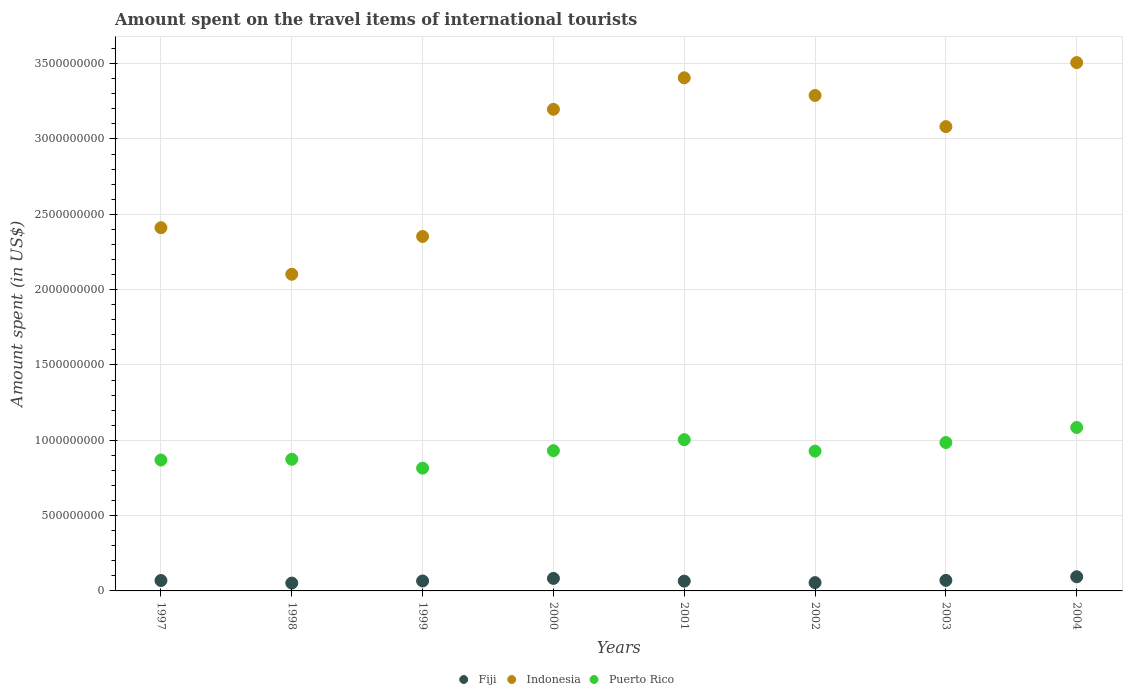What is the amount spent on the travel items of international tourists in Indonesia in 2000?
Ensure brevity in your answer.  3.20e+09. Across all years, what is the maximum amount spent on the travel items of international tourists in Fiji?
Keep it short and to the point. 9.40e+07. Across all years, what is the minimum amount spent on the travel items of international tourists in Puerto Rico?
Provide a short and direct response. 8.15e+08. What is the total amount spent on the travel items of international tourists in Puerto Rico in the graph?
Give a very brief answer. 7.49e+09. What is the difference between the amount spent on the travel items of international tourists in Puerto Rico in 1999 and that in 2003?
Ensure brevity in your answer.  -1.70e+08. What is the difference between the amount spent on the travel items of international tourists in Fiji in 1998 and the amount spent on the travel items of international tourists in Indonesia in 2002?
Your response must be concise. -3.24e+09. What is the average amount spent on the travel items of international tourists in Indonesia per year?
Offer a terse response. 2.92e+09. In the year 1999, what is the difference between the amount spent on the travel items of international tourists in Indonesia and amount spent on the travel items of international tourists in Puerto Rico?
Keep it short and to the point. 1.54e+09. In how many years, is the amount spent on the travel items of international tourists in Puerto Rico greater than 3200000000 US$?
Your answer should be very brief. 0. What is the ratio of the amount spent on the travel items of international tourists in Fiji in 1998 to that in 2004?
Your response must be concise. 0.55. What is the difference between the highest and the second highest amount spent on the travel items of international tourists in Puerto Rico?
Keep it short and to the point. 8.10e+07. What is the difference between the highest and the lowest amount spent on the travel items of international tourists in Fiji?
Your answer should be very brief. 4.20e+07. Is the sum of the amount spent on the travel items of international tourists in Fiji in 2000 and 2001 greater than the maximum amount spent on the travel items of international tourists in Indonesia across all years?
Offer a terse response. No. Does the amount spent on the travel items of international tourists in Fiji monotonically increase over the years?
Make the answer very short. No. Is the amount spent on the travel items of international tourists in Puerto Rico strictly greater than the amount spent on the travel items of international tourists in Indonesia over the years?
Your response must be concise. No. Is the amount spent on the travel items of international tourists in Puerto Rico strictly less than the amount spent on the travel items of international tourists in Fiji over the years?
Make the answer very short. No. Does the graph contain any zero values?
Your answer should be compact. No. How are the legend labels stacked?
Your answer should be compact. Horizontal. What is the title of the graph?
Your response must be concise. Amount spent on the travel items of international tourists. Does "Luxembourg" appear as one of the legend labels in the graph?
Your answer should be very brief. No. What is the label or title of the X-axis?
Offer a terse response. Years. What is the label or title of the Y-axis?
Provide a succinct answer. Amount spent (in US$). What is the Amount spent (in US$) of Fiji in 1997?
Your answer should be compact. 6.90e+07. What is the Amount spent (in US$) in Indonesia in 1997?
Offer a terse response. 2.41e+09. What is the Amount spent (in US$) in Puerto Rico in 1997?
Offer a terse response. 8.69e+08. What is the Amount spent (in US$) in Fiji in 1998?
Make the answer very short. 5.20e+07. What is the Amount spent (in US$) in Indonesia in 1998?
Give a very brief answer. 2.10e+09. What is the Amount spent (in US$) of Puerto Rico in 1998?
Provide a succinct answer. 8.74e+08. What is the Amount spent (in US$) in Fiji in 1999?
Make the answer very short. 6.60e+07. What is the Amount spent (in US$) in Indonesia in 1999?
Your answer should be compact. 2.35e+09. What is the Amount spent (in US$) of Puerto Rico in 1999?
Ensure brevity in your answer.  8.15e+08. What is the Amount spent (in US$) in Fiji in 2000?
Make the answer very short. 8.30e+07. What is the Amount spent (in US$) in Indonesia in 2000?
Offer a terse response. 3.20e+09. What is the Amount spent (in US$) in Puerto Rico in 2000?
Make the answer very short. 9.31e+08. What is the Amount spent (in US$) of Fiji in 2001?
Provide a short and direct response. 6.50e+07. What is the Amount spent (in US$) of Indonesia in 2001?
Ensure brevity in your answer.  3.41e+09. What is the Amount spent (in US$) in Puerto Rico in 2001?
Your answer should be very brief. 1.00e+09. What is the Amount spent (in US$) in Fiji in 2002?
Ensure brevity in your answer.  5.50e+07. What is the Amount spent (in US$) of Indonesia in 2002?
Keep it short and to the point. 3.29e+09. What is the Amount spent (in US$) in Puerto Rico in 2002?
Ensure brevity in your answer.  9.28e+08. What is the Amount spent (in US$) of Fiji in 2003?
Make the answer very short. 7.00e+07. What is the Amount spent (in US$) in Indonesia in 2003?
Provide a succinct answer. 3.08e+09. What is the Amount spent (in US$) of Puerto Rico in 2003?
Keep it short and to the point. 9.85e+08. What is the Amount spent (in US$) in Fiji in 2004?
Your answer should be very brief. 9.40e+07. What is the Amount spent (in US$) of Indonesia in 2004?
Give a very brief answer. 3.51e+09. What is the Amount spent (in US$) of Puerto Rico in 2004?
Provide a short and direct response. 1.08e+09. Across all years, what is the maximum Amount spent (in US$) of Fiji?
Keep it short and to the point. 9.40e+07. Across all years, what is the maximum Amount spent (in US$) in Indonesia?
Offer a terse response. 3.51e+09. Across all years, what is the maximum Amount spent (in US$) of Puerto Rico?
Offer a terse response. 1.08e+09. Across all years, what is the minimum Amount spent (in US$) of Fiji?
Your response must be concise. 5.20e+07. Across all years, what is the minimum Amount spent (in US$) of Indonesia?
Make the answer very short. 2.10e+09. Across all years, what is the minimum Amount spent (in US$) in Puerto Rico?
Your answer should be compact. 8.15e+08. What is the total Amount spent (in US$) in Fiji in the graph?
Your answer should be very brief. 5.54e+08. What is the total Amount spent (in US$) of Indonesia in the graph?
Offer a terse response. 2.33e+1. What is the total Amount spent (in US$) in Puerto Rico in the graph?
Make the answer very short. 7.49e+09. What is the difference between the Amount spent (in US$) of Fiji in 1997 and that in 1998?
Your answer should be very brief. 1.70e+07. What is the difference between the Amount spent (in US$) in Indonesia in 1997 and that in 1998?
Give a very brief answer. 3.09e+08. What is the difference between the Amount spent (in US$) of Puerto Rico in 1997 and that in 1998?
Give a very brief answer. -5.00e+06. What is the difference between the Amount spent (in US$) in Fiji in 1997 and that in 1999?
Ensure brevity in your answer.  3.00e+06. What is the difference between the Amount spent (in US$) of Indonesia in 1997 and that in 1999?
Provide a succinct answer. 5.80e+07. What is the difference between the Amount spent (in US$) in Puerto Rico in 1997 and that in 1999?
Make the answer very short. 5.40e+07. What is the difference between the Amount spent (in US$) of Fiji in 1997 and that in 2000?
Offer a terse response. -1.40e+07. What is the difference between the Amount spent (in US$) of Indonesia in 1997 and that in 2000?
Provide a succinct answer. -7.86e+08. What is the difference between the Amount spent (in US$) in Puerto Rico in 1997 and that in 2000?
Keep it short and to the point. -6.20e+07. What is the difference between the Amount spent (in US$) of Fiji in 1997 and that in 2001?
Your response must be concise. 4.00e+06. What is the difference between the Amount spent (in US$) of Indonesia in 1997 and that in 2001?
Ensure brevity in your answer.  -9.95e+08. What is the difference between the Amount spent (in US$) of Puerto Rico in 1997 and that in 2001?
Give a very brief answer. -1.35e+08. What is the difference between the Amount spent (in US$) in Fiji in 1997 and that in 2002?
Keep it short and to the point. 1.40e+07. What is the difference between the Amount spent (in US$) in Indonesia in 1997 and that in 2002?
Make the answer very short. -8.78e+08. What is the difference between the Amount spent (in US$) of Puerto Rico in 1997 and that in 2002?
Provide a short and direct response. -5.90e+07. What is the difference between the Amount spent (in US$) of Indonesia in 1997 and that in 2003?
Ensure brevity in your answer.  -6.71e+08. What is the difference between the Amount spent (in US$) of Puerto Rico in 1997 and that in 2003?
Keep it short and to the point. -1.16e+08. What is the difference between the Amount spent (in US$) in Fiji in 1997 and that in 2004?
Provide a succinct answer. -2.50e+07. What is the difference between the Amount spent (in US$) in Indonesia in 1997 and that in 2004?
Provide a succinct answer. -1.10e+09. What is the difference between the Amount spent (in US$) of Puerto Rico in 1997 and that in 2004?
Provide a succinct answer. -2.16e+08. What is the difference between the Amount spent (in US$) in Fiji in 1998 and that in 1999?
Provide a short and direct response. -1.40e+07. What is the difference between the Amount spent (in US$) of Indonesia in 1998 and that in 1999?
Give a very brief answer. -2.51e+08. What is the difference between the Amount spent (in US$) of Puerto Rico in 1998 and that in 1999?
Your response must be concise. 5.90e+07. What is the difference between the Amount spent (in US$) in Fiji in 1998 and that in 2000?
Give a very brief answer. -3.10e+07. What is the difference between the Amount spent (in US$) in Indonesia in 1998 and that in 2000?
Your answer should be compact. -1.10e+09. What is the difference between the Amount spent (in US$) of Puerto Rico in 1998 and that in 2000?
Offer a terse response. -5.70e+07. What is the difference between the Amount spent (in US$) in Fiji in 1998 and that in 2001?
Offer a terse response. -1.30e+07. What is the difference between the Amount spent (in US$) in Indonesia in 1998 and that in 2001?
Keep it short and to the point. -1.30e+09. What is the difference between the Amount spent (in US$) in Puerto Rico in 1998 and that in 2001?
Provide a succinct answer. -1.30e+08. What is the difference between the Amount spent (in US$) of Indonesia in 1998 and that in 2002?
Your answer should be very brief. -1.19e+09. What is the difference between the Amount spent (in US$) in Puerto Rico in 1998 and that in 2002?
Make the answer very short. -5.40e+07. What is the difference between the Amount spent (in US$) in Fiji in 1998 and that in 2003?
Offer a very short reply. -1.80e+07. What is the difference between the Amount spent (in US$) in Indonesia in 1998 and that in 2003?
Make the answer very short. -9.80e+08. What is the difference between the Amount spent (in US$) in Puerto Rico in 1998 and that in 2003?
Ensure brevity in your answer.  -1.11e+08. What is the difference between the Amount spent (in US$) in Fiji in 1998 and that in 2004?
Your answer should be very brief. -4.20e+07. What is the difference between the Amount spent (in US$) of Indonesia in 1998 and that in 2004?
Your response must be concise. -1.40e+09. What is the difference between the Amount spent (in US$) of Puerto Rico in 1998 and that in 2004?
Make the answer very short. -2.11e+08. What is the difference between the Amount spent (in US$) in Fiji in 1999 and that in 2000?
Your answer should be very brief. -1.70e+07. What is the difference between the Amount spent (in US$) in Indonesia in 1999 and that in 2000?
Keep it short and to the point. -8.44e+08. What is the difference between the Amount spent (in US$) of Puerto Rico in 1999 and that in 2000?
Your response must be concise. -1.16e+08. What is the difference between the Amount spent (in US$) of Indonesia in 1999 and that in 2001?
Provide a short and direct response. -1.05e+09. What is the difference between the Amount spent (in US$) in Puerto Rico in 1999 and that in 2001?
Make the answer very short. -1.89e+08. What is the difference between the Amount spent (in US$) in Fiji in 1999 and that in 2002?
Ensure brevity in your answer.  1.10e+07. What is the difference between the Amount spent (in US$) in Indonesia in 1999 and that in 2002?
Your answer should be compact. -9.36e+08. What is the difference between the Amount spent (in US$) of Puerto Rico in 1999 and that in 2002?
Your answer should be compact. -1.13e+08. What is the difference between the Amount spent (in US$) in Fiji in 1999 and that in 2003?
Provide a succinct answer. -4.00e+06. What is the difference between the Amount spent (in US$) of Indonesia in 1999 and that in 2003?
Keep it short and to the point. -7.29e+08. What is the difference between the Amount spent (in US$) in Puerto Rico in 1999 and that in 2003?
Provide a succinct answer. -1.70e+08. What is the difference between the Amount spent (in US$) of Fiji in 1999 and that in 2004?
Ensure brevity in your answer.  -2.80e+07. What is the difference between the Amount spent (in US$) of Indonesia in 1999 and that in 2004?
Offer a very short reply. -1.15e+09. What is the difference between the Amount spent (in US$) of Puerto Rico in 1999 and that in 2004?
Make the answer very short. -2.70e+08. What is the difference between the Amount spent (in US$) in Fiji in 2000 and that in 2001?
Make the answer very short. 1.80e+07. What is the difference between the Amount spent (in US$) of Indonesia in 2000 and that in 2001?
Make the answer very short. -2.09e+08. What is the difference between the Amount spent (in US$) in Puerto Rico in 2000 and that in 2001?
Provide a succinct answer. -7.30e+07. What is the difference between the Amount spent (in US$) of Fiji in 2000 and that in 2002?
Your answer should be compact. 2.80e+07. What is the difference between the Amount spent (in US$) of Indonesia in 2000 and that in 2002?
Provide a short and direct response. -9.20e+07. What is the difference between the Amount spent (in US$) of Fiji in 2000 and that in 2003?
Keep it short and to the point. 1.30e+07. What is the difference between the Amount spent (in US$) of Indonesia in 2000 and that in 2003?
Your answer should be compact. 1.15e+08. What is the difference between the Amount spent (in US$) of Puerto Rico in 2000 and that in 2003?
Your answer should be very brief. -5.40e+07. What is the difference between the Amount spent (in US$) in Fiji in 2000 and that in 2004?
Ensure brevity in your answer.  -1.10e+07. What is the difference between the Amount spent (in US$) of Indonesia in 2000 and that in 2004?
Offer a very short reply. -3.10e+08. What is the difference between the Amount spent (in US$) in Puerto Rico in 2000 and that in 2004?
Provide a succinct answer. -1.54e+08. What is the difference between the Amount spent (in US$) of Indonesia in 2001 and that in 2002?
Your response must be concise. 1.17e+08. What is the difference between the Amount spent (in US$) of Puerto Rico in 2001 and that in 2002?
Ensure brevity in your answer.  7.60e+07. What is the difference between the Amount spent (in US$) in Fiji in 2001 and that in 2003?
Give a very brief answer. -5.00e+06. What is the difference between the Amount spent (in US$) in Indonesia in 2001 and that in 2003?
Your answer should be compact. 3.24e+08. What is the difference between the Amount spent (in US$) in Puerto Rico in 2001 and that in 2003?
Your answer should be very brief. 1.90e+07. What is the difference between the Amount spent (in US$) of Fiji in 2001 and that in 2004?
Provide a succinct answer. -2.90e+07. What is the difference between the Amount spent (in US$) of Indonesia in 2001 and that in 2004?
Provide a succinct answer. -1.01e+08. What is the difference between the Amount spent (in US$) in Puerto Rico in 2001 and that in 2004?
Your answer should be very brief. -8.10e+07. What is the difference between the Amount spent (in US$) in Fiji in 2002 and that in 2003?
Keep it short and to the point. -1.50e+07. What is the difference between the Amount spent (in US$) of Indonesia in 2002 and that in 2003?
Give a very brief answer. 2.07e+08. What is the difference between the Amount spent (in US$) of Puerto Rico in 2002 and that in 2003?
Give a very brief answer. -5.70e+07. What is the difference between the Amount spent (in US$) in Fiji in 2002 and that in 2004?
Your answer should be compact. -3.90e+07. What is the difference between the Amount spent (in US$) in Indonesia in 2002 and that in 2004?
Provide a short and direct response. -2.18e+08. What is the difference between the Amount spent (in US$) of Puerto Rico in 2002 and that in 2004?
Provide a succinct answer. -1.57e+08. What is the difference between the Amount spent (in US$) in Fiji in 2003 and that in 2004?
Ensure brevity in your answer.  -2.40e+07. What is the difference between the Amount spent (in US$) of Indonesia in 2003 and that in 2004?
Provide a short and direct response. -4.25e+08. What is the difference between the Amount spent (in US$) in Puerto Rico in 2003 and that in 2004?
Your answer should be compact. -1.00e+08. What is the difference between the Amount spent (in US$) in Fiji in 1997 and the Amount spent (in US$) in Indonesia in 1998?
Offer a terse response. -2.03e+09. What is the difference between the Amount spent (in US$) in Fiji in 1997 and the Amount spent (in US$) in Puerto Rico in 1998?
Your answer should be compact. -8.05e+08. What is the difference between the Amount spent (in US$) in Indonesia in 1997 and the Amount spent (in US$) in Puerto Rico in 1998?
Provide a succinct answer. 1.54e+09. What is the difference between the Amount spent (in US$) of Fiji in 1997 and the Amount spent (in US$) of Indonesia in 1999?
Your answer should be compact. -2.28e+09. What is the difference between the Amount spent (in US$) of Fiji in 1997 and the Amount spent (in US$) of Puerto Rico in 1999?
Provide a succinct answer. -7.46e+08. What is the difference between the Amount spent (in US$) of Indonesia in 1997 and the Amount spent (in US$) of Puerto Rico in 1999?
Your answer should be compact. 1.60e+09. What is the difference between the Amount spent (in US$) of Fiji in 1997 and the Amount spent (in US$) of Indonesia in 2000?
Offer a terse response. -3.13e+09. What is the difference between the Amount spent (in US$) of Fiji in 1997 and the Amount spent (in US$) of Puerto Rico in 2000?
Your answer should be compact. -8.62e+08. What is the difference between the Amount spent (in US$) of Indonesia in 1997 and the Amount spent (in US$) of Puerto Rico in 2000?
Ensure brevity in your answer.  1.48e+09. What is the difference between the Amount spent (in US$) in Fiji in 1997 and the Amount spent (in US$) in Indonesia in 2001?
Your answer should be compact. -3.34e+09. What is the difference between the Amount spent (in US$) in Fiji in 1997 and the Amount spent (in US$) in Puerto Rico in 2001?
Provide a succinct answer. -9.35e+08. What is the difference between the Amount spent (in US$) in Indonesia in 1997 and the Amount spent (in US$) in Puerto Rico in 2001?
Your answer should be very brief. 1.41e+09. What is the difference between the Amount spent (in US$) of Fiji in 1997 and the Amount spent (in US$) of Indonesia in 2002?
Ensure brevity in your answer.  -3.22e+09. What is the difference between the Amount spent (in US$) in Fiji in 1997 and the Amount spent (in US$) in Puerto Rico in 2002?
Your answer should be very brief. -8.59e+08. What is the difference between the Amount spent (in US$) of Indonesia in 1997 and the Amount spent (in US$) of Puerto Rico in 2002?
Offer a terse response. 1.48e+09. What is the difference between the Amount spent (in US$) in Fiji in 1997 and the Amount spent (in US$) in Indonesia in 2003?
Ensure brevity in your answer.  -3.01e+09. What is the difference between the Amount spent (in US$) in Fiji in 1997 and the Amount spent (in US$) in Puerto Rico in 2003?
Offer a terse response. -9.16e+08. What is the difference between the Amount spent (in US$) of Indonesia in 1997 and the Amount spent (in US$) of Puerto Rico in 2003?
Provide a succinct answer. 1.43e+09. What is the difference between the Amount spent (in US$) of Fiji in 1997 and the Amount spent (in US$) of Indonesia in 2004?
Provide a succinct answer. -3.44e+09. What is the difference between the Amount spent (in US$) of Fiji in 1997 and the Amount spent (in US$) of Puerto Rico in 2004?
Ensure brevity in your answer.  -1.02e+09. What is the difference between the Amount spent (in US$) in Indonesia in 1997 and the Amount spent (in US$) in Puerto Rico in 2004?
Your answer should be very brief. 1.33e+09. What is the difference between the Amount spent (in US$) in Fiji in 1998 and the Amount spent (in US$) in Indonesia in 1999?
Provide a short and direct response. -2.30e+09. What is the difference between the Amount spent (in US$) in Fiji in 1998 and the Amount spent (in US$) in Puerto Rico in 1999?
Your response must be concise. -7.63e+08. What is the difference between the Amount spent (in US$) of Indonesia in 1998 and the Amount spent (in US$) of Puerto Rico in 1999?
Keep it short and to the point. 1.29e+09. What is the difference between the Amount spent (in US$) in Fiji in 1998 and the Amount spent (in US$) in Indonesia in 2000?
Your answer should be very brief. -3.14e+09. What is the difference between the Amount spent (in US$) in Fiji in 1998 and the Amount spent (in US$) in Puerto Rico in 2000?
Ensure brevity in your answer.  -8.79e+08. What is the difference between the Amount spent (in US$) in Indonesia in 1998 and the Amount spent (in US$) in Puerto Rico in 2000?
Your answer should be compact. 1.17e+09. What is the difference between the Amount spent (in US$) of Fiji in 1998 and the Amount spent (in US$) of Indonesia in 2001?
Give a very brief answer. -3.35e+09. What is the difference between the Amount spent (in US$) of Fiji in 1998 and the Amount spent (in US$) of Puerto Rico in 2001?
Ensure brevity in your answer.  -9.52e+08. What is the difference between the Amount spent (in US$) in Indonesia in 1998 and the Amount spent (in US$) in Puerto Rico in 2001?
Give a very brief answer. 1.10e+09. What is the difference between the Amount spent (in US$) in Fiji in 1998 and the Amount spent (in US$) in Indonesia in 2002?
Offer a terse response. -3.24e+09. What is the difference between the Amount spent (in US$) of Fiji in 1998 and the Amount spent (in US$) of Puerto Rico in 2002?
Give a very brief answer. -8.76e+08. What is the difference between the Amount spent (in US$) in Indonesia in 1998 and the Amount spent (in US$) in Puerto Rico in 2002?
Provide a short and direct response. 1.17e+09. What is the difference between the Amount spent (in US$) of Fiji in 1998 and the Amount spent (in US$) of Indonesia in 2003?
Your answer should be very brief. -3.03e+09. What is the difference between the Amount spent (in US$) of Fiji in 1998 and the Amount spent (in US$) of Puerto Rico in 2003?
Provide a short and direct response. -9.33e+08. What is the difference between the Amount spent (in US$) of Indonesia in 1998 and the Amount spent (in US$) of Puerto Rico in 2003?
Provide a short and direct response. 1.12e+09. What is the difference between the Amount spent (in US$) of Fiji in 1998 and the Amount spent (in US$) of Indonesia in 2004?
Ensure brevity in your answer.  -3.46e+09. What is the difference between the Amount spent (in US$) of Fiji in 1998 and the Amount spent (in US$) of Puerto Rico in 2004?
Your answer should be very brief. -1.03e+09. What is the difference between the Amount spent (in US$) of Indonesia in 1998 and the Amount spent (in US$) of Puerto Rico in 2004?
Provide a succinct answer. 1.02e+09. What is the difference between the Amount spent (in US$) in Fiji in 1999 and the Amount spent (in US$) in Indonesia in 2000?
Provide a short and direct response. -3.13e+09. What is the difference between the Amount spent (in US$) of Fiji in 1999 and the Amount spent (in US$) of Puerto Rico in 2000?
Provide a succinct answer. -8.65e+08. What is the difference between the Amount spent (in US$) in Indonesia in 1999 and the Amount spent (in US$) in Puerto Rico in 2000?
Your response must be concise. 1.42e+09. What is the difference between the Amount spent (in US$) of Fiji in 1999 and the Amount spent (in US$) of Indonesia in 2001?
Offer a terse response. -3.34e+09. What is the difference between the Amount spent (in US$) in Fiji in 1999 and the Amount spent (in US$) in Puerto Rico in 2001?
Your answer should be very brief. -9.38e+08. What is the difference between the Amount spent (in US$) of Indonesia in 1999 and the Amount spent (in US$) of Puerto Rico in 2001?
Offer a terse response. 1.35e+09. What is the difference between the Amount spent (in US$) in Fiji in 1999 and the Amount spent (in US$) in Indonesia in 2002?
Your response must be concise. -3.22e+09. What is the difference between the Amount spent (in US$) in Fiji in 1999 and the Amount spent (in US$) in Puerto Rico in 2002?
Keep it short and to the point. -8.62e+08. What is the difference between the Amount spent (in US$) of Indonesia in 1999 and the Amount spent (in US$) of Puerto Rico in 2002?
Provide a succinct answer. 1.42e+09. What is the difference between the Amount spent (in US$) of Fiji in 1999 and the Amount spent (in US$) of Indonesia in 2003?
Make the answer very short. -3.02e+09. What is the difference between the Amount spent (in US$) in Fiji in 1999 and the Amount spent (in US$) in Puerto Rico in 2003?
Offer a terse response. -9.19e+08. What is the difference between the Amount spent (in US$) in Indonesia in 1999 and the Amount spent (in US$) in Puerto Rico in 2003?
Provide a succinct answer. 1.37e+09. What is the difference between the Amount spent (in US$) of Fiji in 1999 and the Amount spent (in US$) of Indonesia in 2004?
Provide a succinct answer. -3.44e+09. What is the difference between the Amount spent (in US$) of Fiji in 1999 and the Amount spent (in US$) of Puerto Rico in 2004?
Ensure brevity in your answer.  -1.02e+09. What is the difference between the Amount spent (in US$) of Indonesia in 1999 and the Amount spent (in US$) of Puerto Rico in 2004?
Your answer should be compact. 1.27e+09. What is the difference between the Amount spent (in US$) in Fiji in 2000 and the Amount spent (in US$) in Indonesia in 2001?
Offer a very short reply. -3.32e+09. What is the difference between the Amount spent (in US$) in Fiji in 2000 and the Amount spent (in US$) in Puerto Rico in 2001?
Keep it short and to the point. -9.21e+08. What is the difference between the Amount spent (in US$) in Indonesia in 2000 and the Amount spent (in US$) in Puerto Rico in 2001?
Keep it short and to the point. 2.19e+09. What is the difference between the Amount spent (in US$) of Fiji in 2000 and the Amount spent (in US$) of Indonesia in 2002?
Provide a succinct answer. -3.21e+09. What is the difference between the Amount spent (in US$) in Fiji in 2000 and the Amount spent (in US$) in Puerto Rico in 2002?
Offer a very short reply. -8.45e+08. What is the difference between the Amount spent (in US$) in Indonesia in 2000 and the Amount spent (in US$) in Puerto Rico in 2002?
Offer a very short reply. 2.27e+09. What is the difference between the Amount spent (in US$) in Fiji in 2000 and the Amount spent (in US$) in Indonesia in 2003?
Make the answer very short. -3.00e+09. What is the difference between the Amount spent (in US$) in Fiji in 2000 and the Amount spent (in US$) in Puerto Rico in 2003?
Your answer should be very brief. -9.02e+08. What is the difference between the Amount spent (in US$) of Indonesia in 2000 and the Amount spent (in US$) of Puerto Rico in 2003?
Your answer should be very brief. 2.21e+09. What is the difference between the Amount spent (in US$) of Fiji in 2000 and the Amount spent (in US$) of Indonesia in 2004?
Make the answer very short. -3.42e+09. What is the difference between the Amount spent (in US$) in Fiji in 2000 and the Amount spent (in US$) in Puerto Rico in 2004?
Your response must be concise. -1.00e+09. What is the difference between the Amount spent (in US$) in Indonesia in 2000 and the Amount spent (in US$) in Puerto Rico in 2004?
Your answer should be compact. 2.11e+09. What is the difference between the Amount spent (in US$) in Fiji in 2001 and the Amount spent (in US$) in Indonesia in 2002?
Make the answer very short. -3.22e+09. What is the difference between the Amount spent (in US$) in Fiji in 2001 and the Amount spent (in US$) in Puerto Rico in 2002?
Keep it short and to the point. -8.63e+08. What is the difference between the Amount spent (in US$) in Indonesia in 2001 and the Amount spent (in US$) in Puerto Rico in 2002?
Your response must be concise. 2.48e+09. What is the difference between the Amount spent (in US$) in Fiji in 2001 and the Amount spent (in US$) in Indonesia in 2003?
Offer a very short reply. -3.02e+09. What is the difference between the Amount spent (in US$) in Fiji in 2001 and the Amount spent (in US$) in Puerto Rico in 2003?
Make the answer very short. -9.20e+08. What is the difference between the Amount spent (in US$) in Indonesia in 2001 and the Amount spent (in US$) in Puerto Rico in 2003?
Offer a terse response. 2.42e+09. What is the difference between the Amount spent (in US$) in Fiji in 2001 and the Amount spent (in US$) in Indonesia in 2004?
Provide a short and direct response. -3.44e+09. What is the difference between the Amount spent (in US$) in Fiji in 2001 and the Amount spent (in US$) in Puerto Rico in 2004?
Your answer should be very brief. -1.02e+09. What is the difference between the Amount spent (in US$) in Indonesia in 2001 and the Amount spent (in US$) in Puerto Rico in 2004?
Offer a terse response. 2.32e+09. What is the difference between the Amount spent (in US$) in Fiji in 2002 and the Amount spent (in US$) in Indonesia in 2003?
Give a very brief answer. -3.03e+09. What is the difference between the Amount spent (in US$) in Fiji in 2002 and the Amount spent (in US$) in Puerto Rico in 2003?
Provide a succinct answer. -9.30e+08. What is the difference between the Amount spent (in US$) of Indonesia in 2002 and the Amount spent (in US$) of Puerto Rico in 2003?
Provide a short and direct response. 2.30e+09. What is the difference between the Amount spent (in US$) of Fiji in 2002 and the Amount spent (in US$) of Indonesia in 2004?
Provide a succinct answer. -3.45e+09. What is the difference between the Amount spent (in US$) in Fiji in 2002 and the Amount spent (in US$) in Puerto Rico in 2004?
Provide a short and direct response. -1.03e+09. What is the difference between the Amount spent (in US$) in Indonesia in 2002 and the Amount spent (in US$) in Puerto Rico in 2004?
Make the answer very short. 2.20e+09. What is the difference between the Amount spent (in US$) in Fiji in 2003 and the Amount spent (in US$) in Indonesia in 2004?
Your response must be concise. -3.44e+09. What is the difference between the Amount spent (in US$) of Fiji in 2003 and the Amount spent (in US$) of Puerto Rico in 2004?
Your answer should be very brief. -1.02e+09. What is the difference between the Amount spent (in US$) in Indonesia in 2003 and the Amount spent (in US$) in Puerto Rico in 2004?
Give a very brief answer. 2.00e+09. What is the average Amount spent (in US$) in Fiji per year?
Your answer should be very brief. 6.92e+07. What is the average Amount spent (in US$) of Indonesia per year?
Your answer should be compact. 2.92e+09. What is the average Amount spent (in US$) of Puerto Rico per year?
Your response must be concise. 9.36e+08. In the year 1997, what is the difference between the Amount spent (in US$) in Fiji and Amount spent (in US$) in Indonesia?
Give a very brief answer. -2.34e+09. In the year 1997, what is the difference between the Amount spent (in US$) of Fiji and Amount spent (in US$) of Puerto Rico?
Give a very brief answer. -8.00e+08. In the year 1997, what is the difference between the Amount spent (in US$) in Indonesia and Amount spent (in US$) in Puerto Rico?
Your answer should be compact. 1.54e+09. In the year 1998, what is the difference between the Amount spent (in US$) of Fiji and Amount spent (in US$) of Indonesia?
Your answer should be very brief. -2.05e+09. In the year 1998, what is the difference between the Amount spent (in US$) of Fiji and Amount spent (in US$) of Puerto Rico?
Keep it short and to the point. -8.22e+08. In the year 1998, what is the difference between the Amount spent (in US$) in Indonesia and Amount spent (in US$) in Puerto Rico?
Your response must be concise. 1.23e+09. In the year 1999, what is the difference between the Amount spent (in US$) in Fiji and Amount spent (in US$) in Indonesia?
Make the answer very short. -2.29e+09. In the year 1999, what is the difference between the Amount spent (in US$) of Fiji and Amount spent (in US$) of Puerto Rico?
Make the answer very short. -7.49e+08. In the year 1999, what is the difference between the Amount spent (in US$) in Indonesia and Amount spent (in US$) in Puerto Rico?
Ensure brevity in your answer.  1.54e+09. In the year 2000, what is the difference between the Amount spent (in US$) of Fiji and Amount spent (in US$) of Indonesia?
Your response must be concise. -3.11e+09. In the year 2000, what is the difference between the Amount spent (in US$) in Fiji and Amount spent (in US$) in Puerto Rico?
Offer a terse response. -8.48e+08. In the year 2000, what is the difference between the Amount spent (in US$) in Indonesia and Amount spent (in US$) in Puerto Rico?
Give a very brief answer. 2.27e+09. In the year 2001, what is the difference between the Amount spent (in US$) in Fiji and Amount spent (in US$) in Indonesia?
Provide a short and direct response. -3.34e+09. In the year 2001, what is the difference between the Amount spent (in US$) in Fiji and Amount spent (in US$) in Puerto Rico?
Offer a very short reply. -9.39e+08. In the year 2001, what is the difference between the Amount spent (in US$) of Indonesia and Amount spent (in US$) of Puerto Rico?
Your answer should be compact. 2.40e+09. In the year 2002, what is the difference between the Amount spent (in US$) of Fiji and Amount spent (in US$) of Indonesia?
Keep it short and to the point. -3.23e+09. In the year 2002, what is the difference between the Amount spent (in US$) in Fiji and Amount spent (in US$) in Puerto Rico?
Keep it short and to the point. -8.73e+08. In the year 2002, what is the difference between the Amount spent (in US$) of Indonesia and Amount spent (in US$) of Puerto Rico?
Your answer should be compact. 2.36e+09. In the year 2003, what is the difference between the Amount spent (in US$) of Fiji and Amount spent (in US$) of Indonesia?
Give a very brief answer. -3.01e+09. In the year 2003, what is the difference between the Amount spent (in US$) in Fiji and Amount spent (in US$) in Puerto Rico?
Your response must be concise. -9.15e+08. In the year 2003, what is the difference between the Amount spent (in US$) in Indonesia and Amount spent (in US$) in Puerto Rico?
Your response must be concise. 2.10e+09. In the year 2004, what is the difference between the Amount spent (in US$) in Fiji and Amount spent (in US$) in Indonesia?
Offer a very short reply. -3.41e+09. In the year 2004, what is the difference between the Amount spent (in US$) in Fiji and Amount spent (in US$) in Puerto Rico?
Provide a succinct answer. -9.91e+08. In the year 2004, what is the difference between the Amount spent (in US$) in Indonesia and Amount spent (in US$) in Puerto Rico?
Ensure brevity in your answer.  2.42e+09. What is the ratio of the Amount spent (in US$) in Fiji in 1997 to that in 1998?
Provide a succinct answer. 1.33. What is the ratio of the Amount spent (in US$) in Indonesia in 1997 to that in 1998?
Provide a succinct answer. 1.15. What is the ratio of the Amount spent (in US$) of Fiji in 1997 to that in 1999?
Your answer should be compact. 1.05. What is the ratio of the Amount spent (in US$) in Indonesia in 1997 to that in 1999?
Your answer should be very brief. 1.02. What is the ratio of the Amount spent (in US$) in Puerto Rico in 1997 to that in 1999?
Ensure brevity in your answer.  1.07. What is the ratio of the Amount spent (in US$) of Fiji in 1997 to that in 2000?
Give a very brief answer. 0.83. What is the ratio of the Amount spent (in US$) of Indonesia in 1997 to that in 2000?
Provide a short and direct response. 0.75. What is the ratio of the Amount spent (in US$) in Puerto Rico in 1997 to that in 2000?
Your answer should be very brief. 0.93. What is the ratio of the Amount spent (in US$) in Fiji in 1997 to that in 2001?
Ensure brevity in your answer.  1.06. What is the ratio of the Amount spent (in US$) in Indonesia in 1997 to that in 2001?
Offer a terse response. 0.71. What is the ratio of the Amount spent (in US$) of Puerto Rico in 1997 to that in 2001?
Make the answer very short. 0.87. What is the ratio of the Amount spent (in US$) in Fiji in 1997 to that in 2002?
Give a very brief answer. 1.25. What is the ratio of the Amount spent (in US$) in Indonesia in 1997 to that in 2002?
Give a very brief answer. 0.73. What is the ratio of the Amount spent (in US$) in Puerto Rico in 1997 to that in 2002?
Your answer should be compact. 0.94. What is the ratio of the Amount spent (in US$) in Fiji in 1997 to that in 2003?
Provide a short and direct response. 0.99. What is the ratio of the Amount spent (in US$) in Indonesia in 1997 to that in 2003?
Your answer should be compact. 0.78. What is the ratio of the Amount spent (in US$) in Puerto Rico in 1997 to that in 2003?
Offer a terse response. 0.88. What is the ratio of the Amount spent (in US$) of Fiji in 1997 to that in 2004?
Ensure brevity in your answer.  0.73. What is the ratio of the Amount spent (in US$) of Indonesia in 1997 to that in 2004?
Your answer should be very brief. 0.69. What is the ratio of the Amount spent (in US$) in Puerto Rico in 1997 to that in 2004?
Provide a short and direct response. 0.8. What is the ratio of the Amount spent (in US$) in Fiji in 1998 to that in 1999?
Provide a succinct answer. 0.79. What is the ratio of the Amount spent (in US$) of Indonesia in 1998 to that in 1999?
Your answer should be compact. 0.89. What is the ratio of the Amount spent (in US$) of Puerto Rico in 1998 to that in 1999?
Give a very brief answer. 1.07. What is the ratio of the Amount spent (in US$) in Fiji in 1998 to that in 2000?
Keep it short and to the point. 0.63. What is the ratio of the Amount spent (in US$) in Indonesia in 1998 to that in 2000?
Give a very brief answer. 0.66. What is the ratio of the Amount spent (in US$) in Puerto Rico in 1998 to that in 2000?
Provide a short and direct response. 0.94. What is the ratio of the Amount spent (in US$) of Indonesia in 1998 to that in 2001?
Your answer should be very brief. 0.62. What is the ratio of the Amount spent (in US$) in Puerto Rico in 1998 to that in 2001?
Make the answer very short. 0.87. What is the ratio of the Amount spent (in US$) in Fiji in 1998 to that in 2002?
Provide a short and direct response. 0.95. What is the ratio of the Amount spent (in US$) in Indonesia in 1998 to that in 2002?
Ensure brevity in your answer.  0.64. What is the ratio of the Amount spent (in US$) of Puerto Rico in 1998 to that in 2002?
Keep it short and to the point. 0.94. What is the ratio of the Amount spent (in US$) of Fiji in 1998 to that in 2003?
Your answer should be compact. 0.74. What is the ratio of the Amount spent (in US$) of Indonesia in 1998 to that in 2003?
Keep it short and to the point. 0.68. What is the ratio of the Amount spent (in US$) in Puerto Rico in 1998 to that in 2003?
Provide a succinct answer. 0.89. What is the ratio of the Amount spent (in US$) in Fiji in 1998 to that in 2004?
Your response must be concise. 0.55. What is the ratio of the Amount spent (in US$) of Indonesia in 1998 to that in 2004?
Provide a succinct answer. 0.6. What is the ratio of the Amount spent (in US$) in Puerto Rico in 1998 to that in 2004?
Your answer should be compact. 0.81. What is the ratio of the Amount spent (in US$) in Fiji in 1999 to that in 2000?
Offer a terse response. 0.8. What is the ratio of the Amount spent (in US$) of Indonesia in 1999 to that in 2000?
Provide a short and direct response. 0.74. What is the ratio of the Amount spent (in US$) in Puerto Rico in 1999 to that in 2000?
Your answer should be compact. 0.88. What is the ratio of the Amount spent (in US$) of Fiji in 1999 to that in 2001?
Offer a very short reply. 1.02. What is the ratio of the Amount spent (in US$) of Indonesia in 1999 to that in 2001?
Your response must be concise. 0.69. What is the ratio of the Amount spent (in US$) of Puerto Rico in 1999 to that in 2001?
Ensure brevity in your answer.  0.81. What is the ratio of the Amount spent (in US$) of Indonesia in 1999 to that in 2002?
Offer a very short reply. 0.72. What is the ratio of the Amount spent (in US$) of Puerto Rico in 1999 to that in 2002?
Keep it short and to the point. 0.88. What is the ratio of the Amount spent (in US$) in Fiji in 1999 to that in 2003?
Provide a short and direct response. 0.94. What is the ratio of the Amount spent (in US$) in Indonesia in 1999 to that in 2003?
Provide a succinct answer. 0.76. What is the ratio of the Amount spent (in US$) of Puerto Rico in 1999 to that in 2003?
Offer a terse response. 0.83. What is the ratio of the Amount spent (in US$) of Fiji in 1999 to that in 2004?
Make the answer very short. 0.7. What is the ratio of the Amount spent (in US$) of Indonesia in 1999 to that in 2004?
Offer a very short reply. 0.67. What is the ratio of the Amount spent (in US$) of Puerto Rico in 1999 to that in 2004?
Ensure brevity in your answer.  0.75. What is the ratio of the Amount spent (in US$) of Fiji in 2000 to that in 2001?
Offer a terse response. 1.28. What is the ratio of the Amount spent (in US$) in Indonesia in 2000 to that in 2001?
Give a very brief answer. 0.94. What is the ratio of the Amount spent (in US$) of Puerto Rico in 2000 to that in 2001?
Provide a succinct answer. 0.93. What is the ratio of the Amount spent (in US$) in Fiji in 2000 to that in 2002?
Offer a terse response. 1.51. What is the ratio of the Amount spent (in US$) of Indonesia in 2000 to that in 2002?
Give a very brief answer. 0.97. What is the ratio of the Amount spent (in US$) of Puerto Rico in 2000 to that in 2002?
Offer a very short reply. 1. What is the ratio of the Amount spent (in US$) in Fiji in 2000 to that in 2003?
Offer a terse response. 1.19. What is the ratio of the Amount spent (in US$) in Indonesia in 2000 to that in 2003?
Ensure brevity in your answer.  1.04. What is the ratio of the Amount spent (in US$) of Puerto Rico in 2000 to that in 2003?
Ensure brevity in your answer.  0.95. What is the ratio of the Amount spent (in US$) in Fiji in 2000 to that in 2004?
Give a very brief answer. 0.88. What is the ratio of the Amount spent (in US$) in Indonesia in 2000 to that in 2004?
Provide a short and direct response. 0.91. What is the ratio of the Amount spent (in US$) of Puerto Rico in 2000 to that in 2004?
Give a very brief answer. 0.86. What is the ratio of the Amount spent (in US$) in Fiji in 2001 to that in 2002?
Keep it short and to the point. 1.18. What is the ratio of the Amount spent (in US$) in Indonesia in 2001 to that in 2002?
Offer a very short reply. 1.04. What is the ratio of the Amount spent (in US$) of Puerto Rico in 2001 to that in 2002?
Your answer should be compact. 1.08. What is the ratio of the Amount spent (in US$) of Indonesia in 2001 to that in 2003?
Your answer should be very brief. 1.11. What is the ratio of the Amount spent (in US$) of Puerto Rico in 2001 to that in 2003?
Offer a very short reply. 1.02. What is the ratio of the Amount spent (in US$) in Fiji in 2001 to that in 2004?
Your response must be concise. 0.69. What is the ratio of the Amount spent (in US$) of Indonesia in 2001 to that in 2004?
Provide a short and direct response. 0.97. What is the ratio of the Amount spent (in US$) in Puerto Rico in 2001 to that in 2004?
Ensure brevity in your answer.  0.93. What is the ratio of the Amount spent (in US$) of Fiji in 2002 to that in 2003?
Provide a short and direct response. 0.79. What is the ratio of the Amount spent (in US$) in Indonesia in 2002 to that in 2003?
Ensure brevity in your answer.  1.07. What is the ratio of the Amount spent (in US$) in Puerto Rico in 2002 to that in 2003?
Your answer should be compact. 0.94. What is the ratio of the Amount spent (in US$) in Fiji in 2002 to that in 2004?
Offer a terse response. 0.59. What is the ratio of the Amount spent (in US$) of Indonesia in 2002 to that in 2004?
Keep it short and to the point. 0.94. What is the ratio of the Amount spent (in US$) of Puerto Rico in 2002 to that in 2004?
Offer a very short reply. 0.86. What is the ratio of the Amount spent (in US$) in Fiji in 2003 to that in 2004?
Provide a succinct answer. 0.74. What is the ratio of the Amount spent (in US$) of Indonesia in 2003 to that in 2004?
Provide a short and direct response. 0.88. What is the ratio of the Amount spent (in US$) in Puerto Rico in 2003 to that in 2004?
Your answer should be very brief. 0.91. What is the difference between the highest and the second highest Amount spent (in US$) of Fiji?
Ensure brevity in your answer.  1.10e+07. What is the difference between the highest and the second highest Amount spent (in US$) of Indonesia?
Your answer should be very brief. 1.01e+08. What is the difference between the highest and the second highest Amount spent (in US$) in Puerto Rico?
Your answer should be compact. 8.10e+07. What is the difference between the highest and the lowest Amount spent (in US$) in Fiji?
Ensure brevity in your answer.  4.20e+07. What is the difference between the highest and the lowest Amount spent (in US$) in Indonesia?
Ensure brevity in your answer.  1.40e+09. What is the difference between the highest and the lowest Amount spent (in US$) of Puerto Rico?
Give a very brief answer. 2.70e+08. 